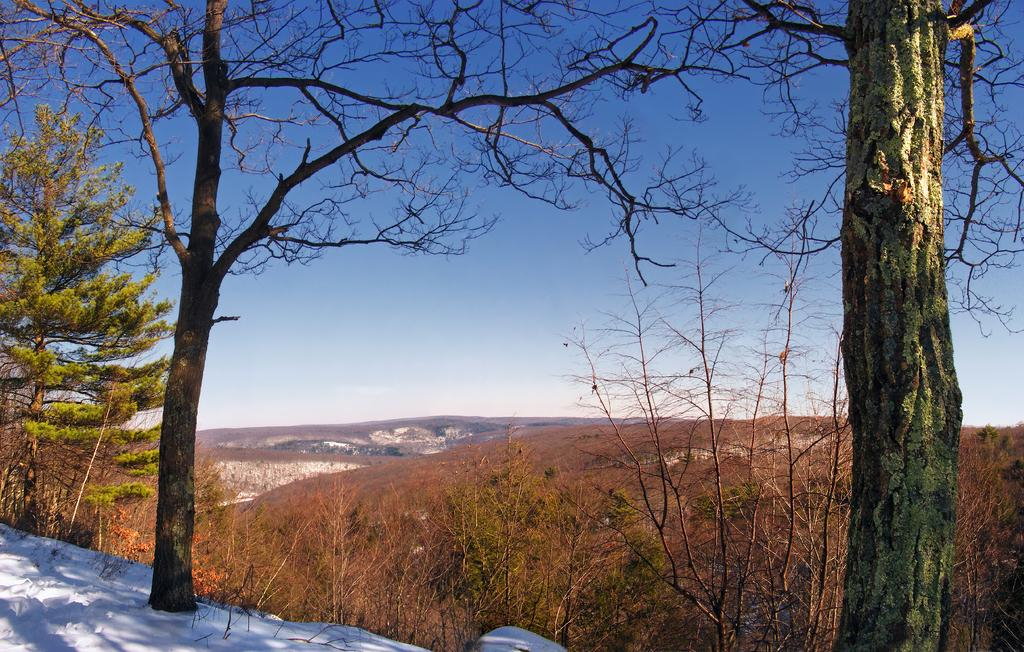What type of vegetation can be seen in the image? There are trees and plants in the image. What type of terrain is visible in the image? There are hills in the image. What is visible in the background of the image? The sky is visible in the background of the image. What is the weather like in the image? The presence of snow in the bottom left corner of the image suggests that it is snowing or has recently snowed. What type of circle can be seen in the image? There is no circle present in the image. What type of can is visible in the image? There is no can present in the image. 